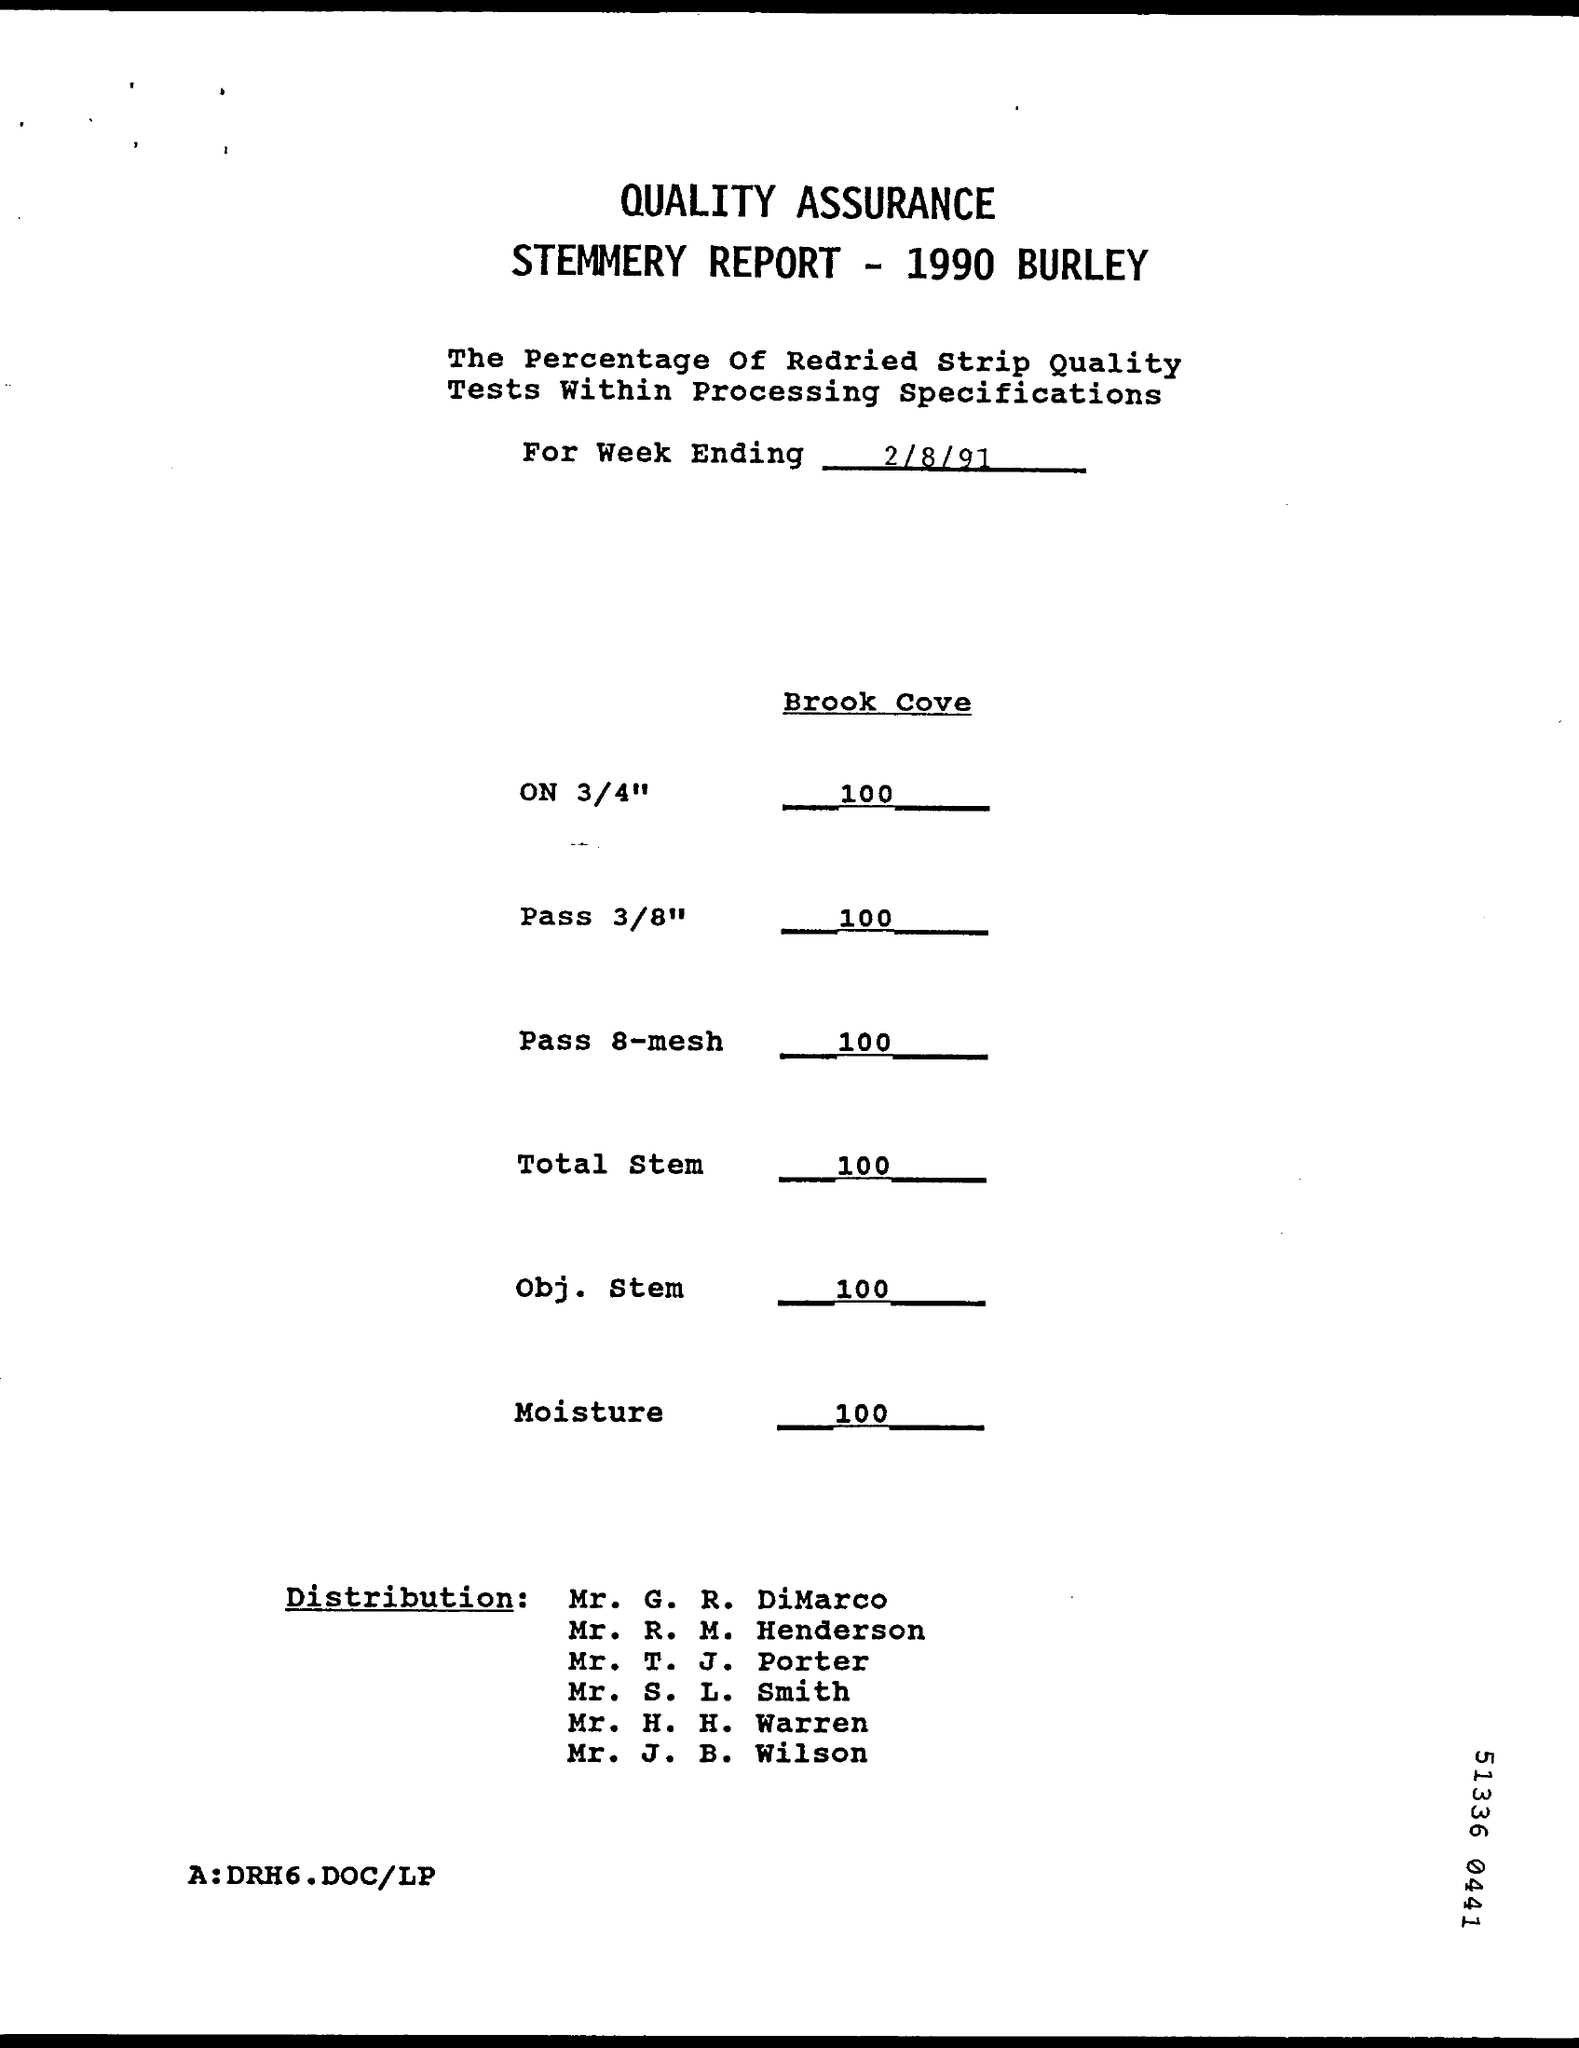Mention a couple of crucial points in this snapshot. The date provided is 2/8/91. The value of moisture is 100... The document title is "QUALITY ASSURANCE STEMMERY REPORT - 1990 BURLEY". 